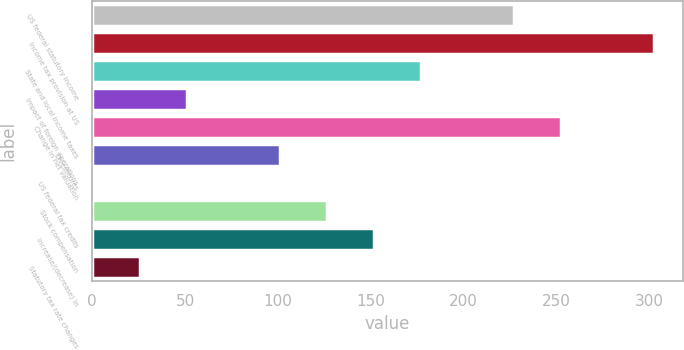<chart> <loc_0><loc_0><loc_500><loc_500><bar_chart><fcel>US federal statutory income<fcel>Income tax provision at US<fcel>State and local income taxes<fcel>Impact of foreign operations<fcel>Change in net valuation<fcel>Divestitures<fcel>US federal tax credits<fcel>Stock compensation<fcel>Increase/(decrease) in<fcel>Statutory tax rate changes<nl><fcel>227.13<fcel>302.61<fcel>176.81<fcel>51.01<fcel>252.29<fcel>101.33<fcel>0.69<fcel>126.49<fcel>151.65<fcel>25.85<nl></chart> 